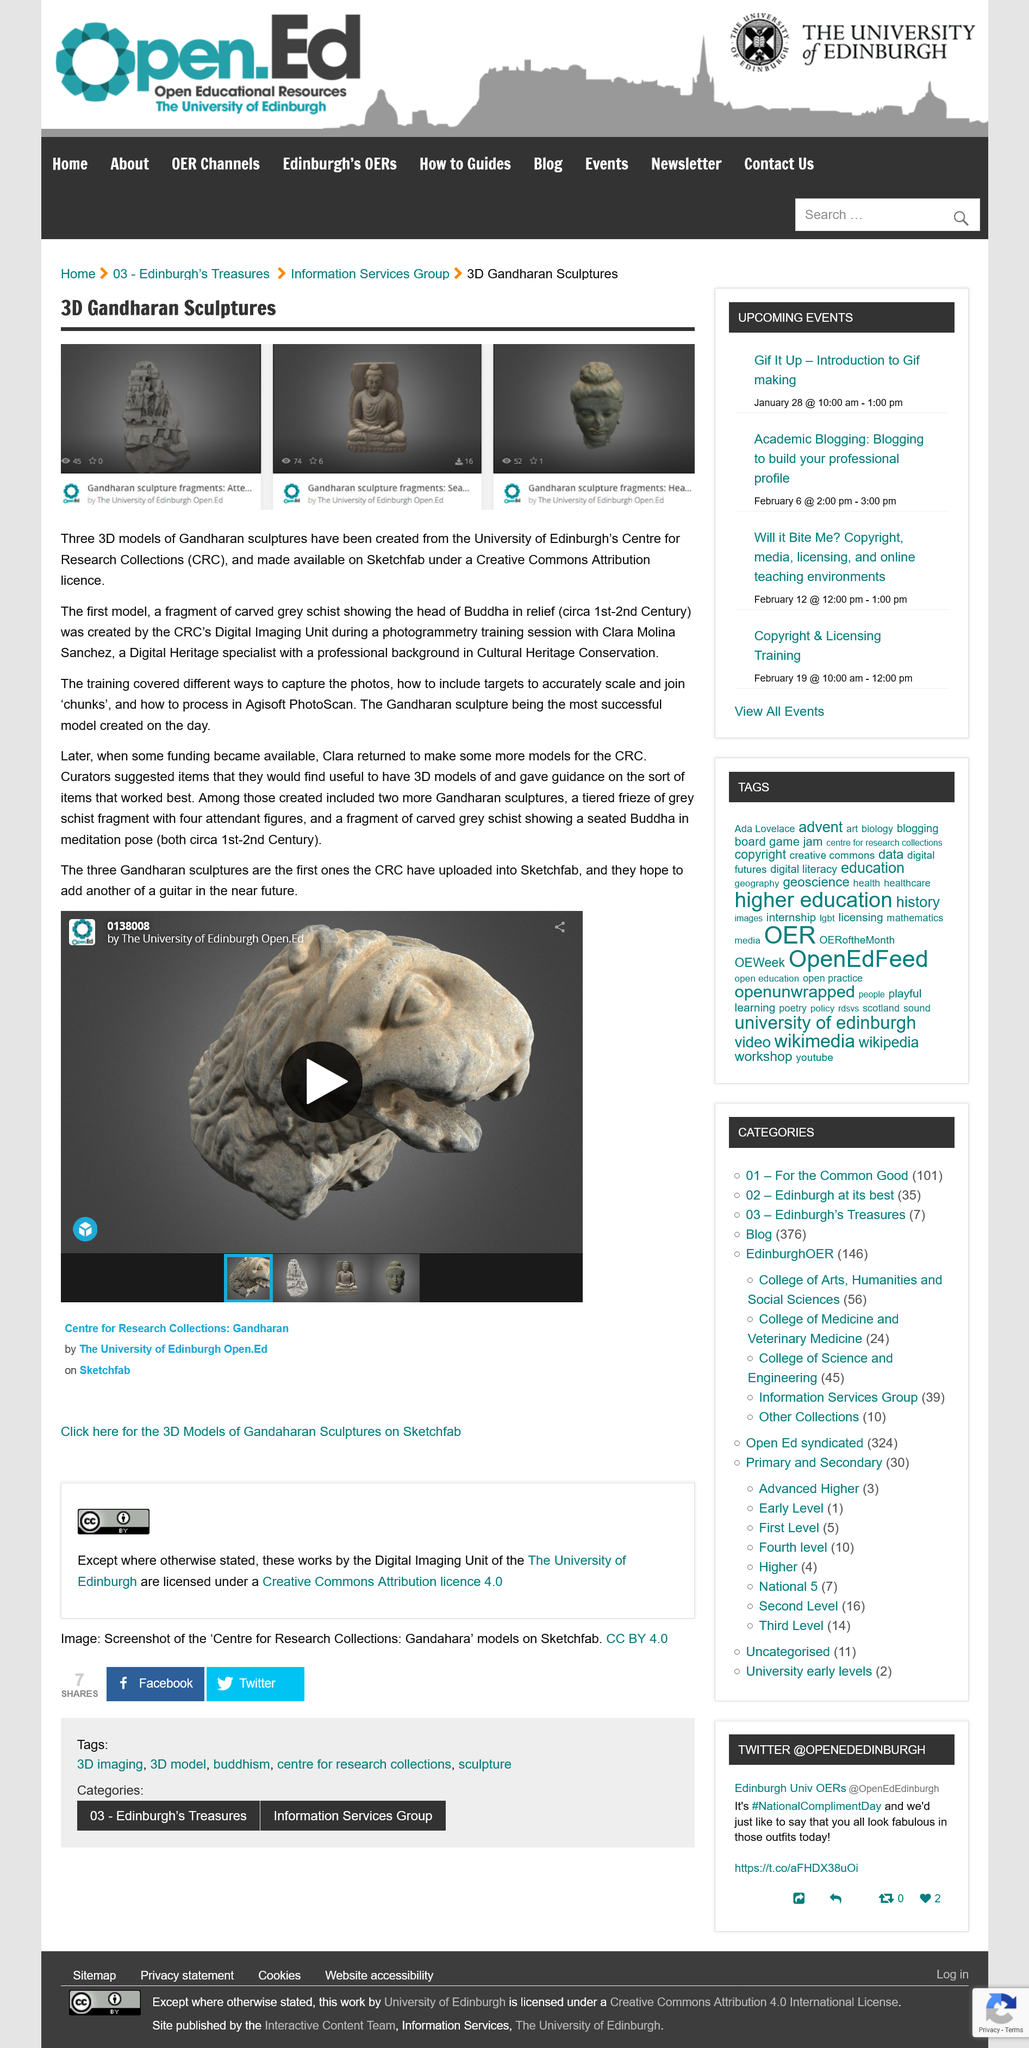Give some essential details in this illustration. The CRC has uploaded three sculptures. The CRC hopes to upload a guitar in the near future. Clara Molina Sanchez is a Digital Heritage specialist with a professional background in Cultural Heritage Conservation. Three 3D models of Gandharan sculptures have been created at the University of Edinburgh. The acronym CRC stands for Centre for Research Collections. 